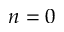Convert formula to latex. <formula><loc_0><loc_0><loc_500><loc_500>n = 0</formula> 